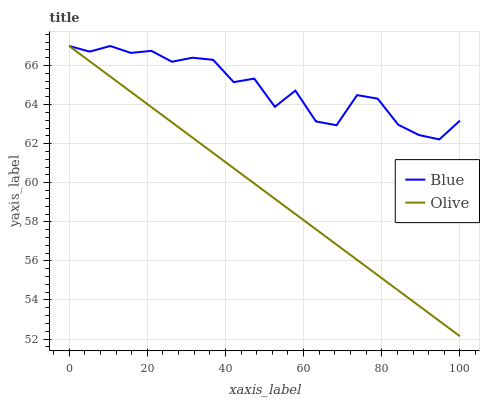Does Olive have the minimum area under the curve?
Answer yes or no. Yes. Does Blue have the maximum area under the curve?
Answer yes or no. Yes. Does Olive have the maximum area under the curve?
Answer yes or no. No. Is Olive the smoothest?
Answer yes or no. Yes. Is Blue the roughest?
Answer yes or no. Yes. Is Olive the roughest?
Answer yes or no. No. Does Olive have the lowest value?
Answer yes or no. Yes. Does Olive have the highest value?
Answer yes or no. Yes. Does Blue intersect Olive?
Answer yes or no. Yes. Is Blue less than Olive?
Answer yes or no. No. Is Blue greater than Olive?
Answer yes or no. No. 